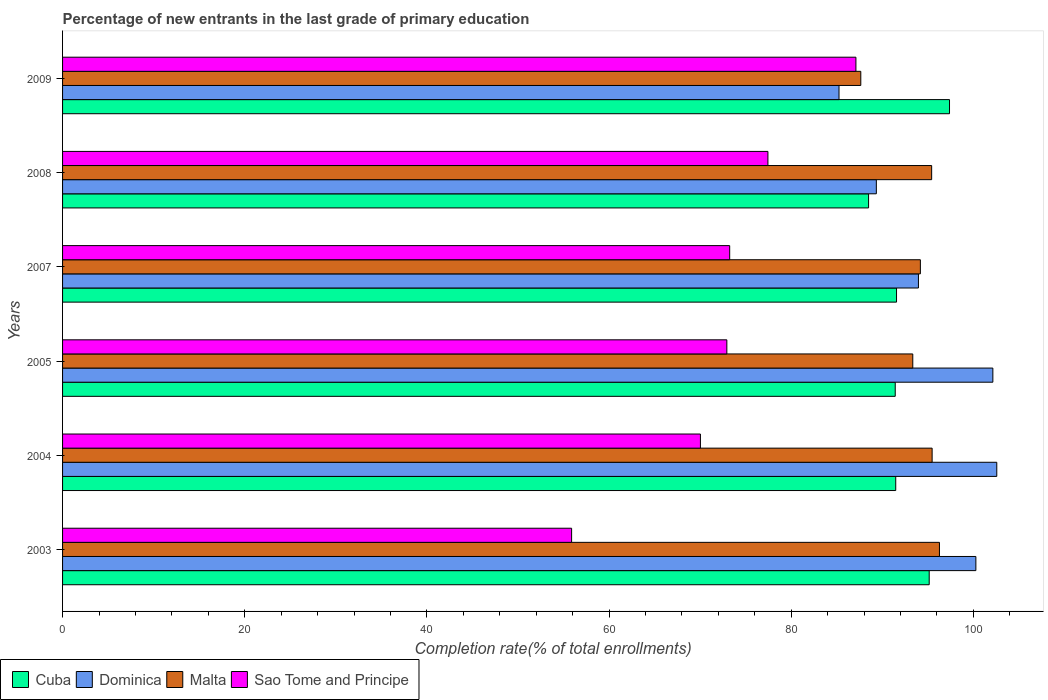How many different coloured bars are there?
Offer a terse response. 4. How many groups of bars are there?
Keep it short and to the point. 6. Are the number of bars per tick equal to the number of legend labels?
Give a very brief answer. Yes. How many bars are there on the 1st tick from the top?
Offer a terse response. 4. How many bars are there on the 3rd tick from the bottom?
Make the answer very short. 4. What is the label of the 4th group of bars from the top?
Provide a short and direct response. 2005. What is the percentage of new entrants in Sao Tome and Principe in 2003?
Ensure brevity in your answer.  55.89. Across all years, what is the maximum percentage of new entrants in Dominica?
Your response must be concise. 102.57. Across all years, what is the minimum percentage of new entrants in Cuba?
Provide a succinct answer. 88.5. What is the total percentage of new entrants in Cuba in the graph?
Give a very brief answer. 555.5. What is the difference between the percentage of new entrants in Dominica in 2003 and that in 2008?
Offer a very short reply. 10.93. What is the difference between the percentage of new entrants in Dominica in 2008 and the percentage of new entrants in Malta in 2007?
Provide a succinct answer. -4.83. What is the average percentage of new entrants in Malta per year?
Give a very brief answer. 93.72. In the year 2005, what is the difference between the percentage of new entrants in Dominica and percentage of new entrants in Sao Tome and Principe?
Keep it short and to the point. 29.21. What is the ratio of the percentage of new entrants in Sao Tome and Principe in 2005 to that in 2008?
Provide a succinct answer. 0.94. Is the difference between the percentage of new entrants in Dominica in 2007 and 2009 greater than the difference between the percentage of new entrants in Sao Tome and Principe in 2007 and 2009?
Make the answer very short. Yes. What is the difference between the highest and the second highest percentage of new entrants in Dominica?
Your answer should be compact. 0.43. What is the difference between the highest and the lowest percentage of new entrants in Sao Tome and Principe?
Your answer should be very brief. 31.22. In how many years, is the percentage of new entrants in Cuba greater than the average percentage of new entrants in Cuba taken over all years?
Provide a succinct answer. 2. Is the sum of the percentage of new entrants in Sao Tome and Principe in 2004 and 2005 greater than the maximum percentage of new entrants in Malta across all years?
Offer a very short reply. Yes. Is it the case that in every year, the sum of the percentage of new entrants in Malta and percentage of new entrants in Cuba is greater than the sum of percentage of new entrants in Sao Tome and Principe and percentage of new entrants in Dominica?
Ensure brevity in your answer.  Yes. What does the 2nd bar from the top in 2003 represents?
Give a very brief answer. Malta. What does the 3rd bar from the bottom in 2007 represents?
Provide a succinct answer. Malta. Is it the case that in every year, the sum of the percentage of new entrants in Dominica and percentage of new entrants in Sao Tome and Principe is greater than the percentage of new entrants in Cuba?
Offer a terse response. Yes. How many bars are there?
Offer a very short reply. 24. Are all the bars in the graph horizontal?
Give a very brief answer. Yes. What is the difference between two consecutive major ticks on the X-axis?
Your answer should be very brief. 20. Are the values on the major ticks of X-axis written in scientific E-notation?
Give a very brief answer. No. Does the graph contain grids?
Offer a terse response. No. Where does the legend appear in the graph?
Provide a short and direct response. Bottom left. How are the legend labels stacked?
Your response must be concise. Horizontal. What is the title of the graph?
Your answer should be compact. Percentage of new entrants in the last grade of primary education. Does "Iran" appear as one of the legend labels in the graph?
Keep it short and to the point. No. What is the label or title of the X-axis?
Provide a short and direct response. Completion rate(% of total enrollments). What is the Completion rate(% of total enrollments) of Cuba in 2003?
Give a very brief answer. 95.15. What is the Completion rate(% of total enrollments) of Dominica in 2003?
Keep it short and to the point. 100.28. What is the Completion rate(% of total enrollments) of Malta in 2003?
Give a very brief answer. 96.28. What is the Completion rate(% of total enrollments) in Sao Tome and Principe in 2003?
Ensure brevity in your answer.  55.89. What is the Completion rate(% of total enrollments) of Cuba in 2004?
Give a very brief answer. 91.48. What is the Completion rate(% of total enrollments) of Dominica in 2004?
Offer a very short reply. 102.57. What is the Completion rate(% of total enrollments) in Malta in 2004?
Your response must be concise. 95.47. What is the Completion rate(% of total enrollments) of Sao Tome and Principe in 2004?
Make the answer very short. 70.03. What is the Completion rate(% of total enrollments) in Cuba in 2005?
Keep it short and to the point. 91.42. What is the Completion rate(% of total enrollments) in Dominica in 2005?
Offer a terse response. 102.14. What is the Completion rate(% of total enrollments) of Malta in 2005?
Keep it short and to the point. 93.35. What is the Completion rate(% of total enrollments) in Sao Tome and Principe in 2005?
Offer a terse response. 72.93. What is the Completion rate(% of total enrollments) in Cuba in 2007?
Ensure brevity in your answer.  91.57. What is the Completion rate(% of total enrollments) of Dominica in 2007?
Your answer should be very brief. 93.97. What is the Completion rate(% of total enrollments) in Malta in 2007?
Provide a succinct answer. 94.18. What is the Completion rate(% of total enrollments) of Sao Tome and Principe in 2007?
Offer a terse response. 73.25. What is the Completion rate(% of total enrollments) in Cuba in 2008?
Offer a very short reply. 88.5. What is the Completion rate(% of total enrollments) of Dominica in 2008?
Your response must be concise. 89.35. What is the Completion rate(% of total enrollments) of Malta in 2008?
Your answer should be very brief. 95.42. What is the Completion rate(% of total enrollments) of Sao Tome and Principe in 2008?
Offer a terse response. 77.45. What is the Completion rate(% of total enrollments) in Cuba in 2009?
Keep it short and to the point. 97.38. What is the Completion rate(% of total enrollments) in Dominica in 2009?
Your answer should be compact. 85.25. What is the Completion rate(% of total enrollments) of Malta in 2009?
Make the answer very short. 87.64. What is the Completion rate(% of total enrollments) of Sao Tome and Principe in 2009?
Provide a short and direct response. 87.11. Across all years, what is the maximum Completion rate(% of total enrollments) of Cuba?
Give a very brief answer. 97.38. Across all years, what is the maximum Completion rate(% of total enrollments) in Dominica?
Provide a succinct answer. 102.57. Across all years, what is the maximum Completion rate(% of total enrollments) of Malta?
Make the answer very short. 96.28. Across all years, what is the maximum Completion rate(% of total enrollments) of Sao Tome and Principe?
Provide a succinct answer. 87.11. Across all years, what is the minimum Completion rate(% of total enrollments) of Cuba?
Your answer should be very brief. 88.5. Across all years, what is the minimum Completion rate(% of total enrollments) in Dominica?
Make the answer very short. 85.25. Across all years, what is the minimum Completion rate(% of total enrollments) of Malta?
Offer a terse response. 87.64. Across all years, what is the minimum Completion rate(% of total enrollments) of Sao Tome and Principe?
Offer a very short reply. 55.89. What is the total Completion rate(% of total enrollments) in Cuba in the graph?
Give a very brief answer. 555.5. What is the total Completion rate(% of total enrollments) of Dominica in the graph?
Offer a very short reply. 573.56. What is the total Completion rate(% of total enrollments) in Malta in the graph?
Offer a very short reply. 562.35. What is the total Completion rate(% of total enrollments) of Sao Tome and Principe in the graph?
Offer a terse response. 436.66. What is the difference between the Completion rate(% of total enrollments) in Cuba in 2003 and that in 2004?
Provide a succinct answer. 3.68. What is the difference between the Completion rate(% of total enrollments) in Dominica in 2003 and that in 2004?
Offer a very short reply. -2.3. What is the difference between the Completion rate(% of total enrollments) in Malta in 2003 and that in 2004?
Provide a short and direct response. 0.81. What is the difference between the Completion rate(% of total enrollments) in Sao Tome and Principe in 2003 and that in 2004?
Offer a very short reply. -14.14. What is the difference between the Completion rate(% of total enrollments) in Cuba in 2003 and that in 2005?
Provide a succinct answer. 3.73. What is the difference between the Completion rate(% of total enrollments) of Dominica in 2003 and that in 2005?
Your answer should be very brief. -1.86. What is the difference between the Completion rate(% of total enrollments) of Malta in 2003 and that in 2005?
Make the answer very short. 2.93. What is the difference between the Completion rate(% of total enrollments) of Sao Tome and Principe in 2003 and that in 2005?
Ensure brevity in your answer.  -17.04. What is the difference between the Completion rate(% of total enrollments) in Cuba in 2003 and that in 2007?
Offer a very short reply. 3.59. What is the difference between the Completion rate(% of total enrollments) of Dominica in 2003 and that in 2007?
Offer a terse response. 6.31. What is the difference between the Completion rate(% of total enrollments) in Malta in 2003 and that in 2007?
Keep it short and to the point. 2.1. What is the difference between the Completion rate(% of total enrollments) in Sao Tome and Principe in 2003 and that in 2007?
Your response must be concise. -17.36. What is the difference between the Completion rate(% of total enrollments) of Cuba in 2003 and that in 2008?
Keep it short and to the point. 6.66. What is the difference between the Completion rate(% of total enrollments) of Dominica in 2003 and that in 2008?
Your response must be concise. 10.93. What is the difference between the Completion rate(% of total enrollments) of Malta in 2003 and that in 2008?
Ensure brevity in your answer.  0.86. What is the difference between the Completion rate(% of total enrollments) in Sao Tome and Principe in 2003 and that in 2008?
Provide a succinct answer. -21.56. What is the difference between the Completion rate(% of total enrollments) in Cuba in 2003 and that in 2009?
Offer a very short reply. -2.23. What is the difference between the Completion rate(% of total enrollments) in Dominica in 2003 and that in 2009?
Give a very brief answer. 15.03. What is the difference between the Completion rate(% of total enrollments) in Malta in 2003 and that in 2009?
Offer a very short reply. 8.64. What is the difference between the Completion rate(% of total enrollments) in Sao Tome and Principe in 2003 and that in 2009?
Ensure brevity in your answer.  -31.22. What is the difference between the Completion rate(% of total enrollments) of Cuba in 2004 and that in 2005?
Offer a very short reply. 0.06. What is the difference between the Completion rate(% of total enrollments) of Dominica in 2004 and that in 2005?
Your response must be concise. 0.43. What is the difference between the Completion rate(% of total enrollments) of Malta in 2004 and that in 2005?
Your answer should be very brief. 2.12. What is the difference between the Completion rate(% of total enrollments) in Sao Tome and Principe in 2004 and that in 2005?
Your answer should be compact. -2.9. What is the difference between the Completion rate(% of total enrollments) in Cuba in 2004 and that in 2007?
Offer a very short reply. -0.09. What is the difference between the Completion rate(% of total enrollments) of Dominica in 2004 and that in 2007?
Your answer should be compact. 8.6. What is the difference between the Completion rate(% of total enrollments) of Malta in 2004 and that in 2007?
Your answer should be very brief. 1.29. What is the difference between the Completion rate(% of total enrollments) in Sao Tome and Principe in 2004 and that in 2007?
Provide a short and direct response. -3.21. What is the difference between the Completion rate(% of total enrollments) in Cuba in 2004 and that in 2008?
Offer a very short reply. 2.98. What is the difference between the Completion rate(% of total enrollments) of Dominica in 2004 and that in 2008?
Provide a succinct answer. 13.22. What is the difference between the Completion rate(% of total enrollments) of Malta in 2004 and that in 2008?
Ensure brevity in your answer.  0.05. What is the difference between the Completion rate(% of total enrollments) in Sao Tome and Principe in 2004 and that in 2008?
Provide a succinct answer. -7.41. What is the difference between the Completion rate(% of total enrollments) in Cuba in 2004 and that in 2009?
Your response must be concise. -5.91. What is the difference between the Completion rate(% of total enrollments) of Dominica in 2004 and that in 2009?
Offer a terse response. 17.32. What is the difference between the Completion rate(% of total enrollments) in Malta in 2004 and that in 2009?
Offer a very short reply. 7.83. What is the difference between the Completion rate(% of total enrollments) of Sao Tome and Principe in 2004 and that in 2009?
Offer a terse response. -17.07. What is the difference between the Completion rate(% of total enrollments) in Cuba in 2005 and that in 2007?
Make the answer very short. -0.14. What is the difference between the Completion rate(% of total enrollments) in Dominica in 2005 and that in 2007?
Make the answer very short. 8.17. What is the difference between the Completion rate(% of total enrollments) of Malta in 2005 and that in 2007?
Provide a succinct answer. -0.83. What is the difference between the Completion rate(% of total enrollments) in Sao Tome and Principe in 2005 and that in 2007?
Your response must be concise. -0.31. What is the difference between the Completion rate(% of total enrollments) of Cuba in 2005 and that in 2008?
Provide a succinct answer. 2.93. What is the difference between the Completion rate(% of total enrollments) of Dominica in 2005 and that in 2008?
Ensure brevity in your answer.  12.79. What is the difference between the Completion rate(% of total enrollments) of Malta in 2005 and that in 2008?
Provide a short and direct response. -2.07. What is the difference between the Completion rate(% of total enrollments) of Sao Tome and Principe in 2005 and that in 2008?
Provide a succinct answer. -4.51. What is the difference between the Completion rate(% of total enrollments) in Cuba in 2005 and that in 2009?
Ensure brevity in your answer.  -5.96. What is the difference between the Completion rate(% of total enrollments) in Dominica in 2005 and that in 2009?
Offer a very short reply. 16.89. What is the difference between the Completion rate(% of total enrollments) in Malta in 2005 and that in 2009?
Give a very brief answer. 5.71. What is the difference between the Completion rate(% of total enrollments) of Sao Tome and Principe in 2005 and that in 2009?
Keep it short and to the point. -14.17. What is the difference between the Completion rate(% of total enrollments) in Cuba in 2007 and that in 2008?
Keep it short and to the point. 3.07. What is the difference between the Completion rate(% of total enrollments) of Dominica in 2007 and that in 2008?
Ensure brevity in your answer.  4.62. What is the difference between the Completion rate(% of total enrollments) in Malta in 2007 and that in 2008?
Offer a terse response. -1.24. What is the difference between the Completion rate(% of total enrollments) in Sao Tome and Principe in 2007 and that in 2008?
Offer a very short reply. -4.2. What is the difference between the Completion rate(% of total enrollments) in Cuba in 2007 and that in 2009?
Your answer should be very brief. -5.82. What is the difference between the Completion rate(% of total enrollments) in Dominica in 2007 and that in 2009?
Your answer should be very brief. 8.72. What is the difference between the Completion rate(% of total enrollments) of Malta in 2007 and that in 2009?
Your answer should be very brief. 6.54. What is the difference between the Completion rate(% of total enrollments) in Sao Tome and Principe in 2007 and that in 2009?
Offer a terse response. -13.86. What is the difference between the Completion rate(% of total enrollments) in Cuba in 2008 and that in 2009?
Make the answer very short. -8.89. What is the difference between the Completion rate(% of total enrollments) of Dominica in 2008 and that in 2009?
Provide a short and direct response. 4.1. What is the difference between the Completion rate(% of total enrollments) of Malta in 2008 and that in 2009?
Your answer should be compact. 7.78. What is the difference between the Completion rate(% of total enrollments) of Sao Tome and Principe in 2008 and that in 2009?
Make the answer very short. -9.66. What is the difference between the Completion rate(% of total enrollments) in Cuba in 2003 and the Completion rate(% of total enrollments) in Dominica in 2004?
Your response must be concise. -7.42. What is the difference between the Completion rate(% of total enrollments) in Cuba in 2003 and the Completion rate(% of total enrollments) in Malta in 2004?
Make the answer very short. -0.32. What is the difference between the Completion rate(% of total enrollments) in Cuba in 2003 and the Completion rate(% of total enrollments) in Sao Tome and Principe in 2004?
Your answer should be compact. 25.12. What is the difference between the Completion rate(% of total enrollments) in Dominica in 2003 and the Completion rate(% of total enrollments) in Malta in 2004?
Provide a short and direct response. 4.8. What is the difference between the Completion rate(% of total enrollments) in Dominica in 2003 and the Completion rate(% of total enrollments) in Sao Tome and Principe in 2004?
Make the answer very short. 30.24. What is the difference between the Completion rate(% of total enrollments) of Malta in 2003 and the Completion rate(% of total enrollments) of Sao Tome and Principe in 2004?
Provide a short and direct response. 26.25. What is the difference between the Completion rate(% of total enrollments) of Cuba in 2003 and the Completion rate(% of total enrollments) of Dominica in 2005?
Offer a very short reply. -6.99. What is the difference between the Completion rate(% of total enrollments) of Cuba in 2003 and the Completion rate(% of total enrollments) of Malta in 2005?
Your answer should be very brief. 1.8. What is the difference between the Completion rate(% of total enrollments) in Cuba in 2003 and the Completion rate(% of total enrollments) in Sao Tome and Principe in 2005?
Your answer should be compact. 22.22. What is the difference between the Completion rate(% of total enrollments) in Dominica in 2003 and the Completion rate(% of total enrollments) in Malta in 2005?
Provide a short and direct response. 6.93. What is the difference between the Completion rate(% of total enrollments) of Dominica in 2003 and the Completion rate(% of total enrollments) of Sao Tome and Principe in 2005?
Provide a short and direct response. 27.34. What is the difference between the Completion rate(% of total enrollments) in Malta in 2003 and the Completion rate(% of total enrollments) in Sao Tome and Principe in 2005?
Offer a very short reply. 23.34. What is the difference between the Completion rate(% of total enrollments) in Cuba in 2003 and the Completion rate(% of total enrollments) in Dominica in 2007?
Ensure brevity in your answer.  1.18. What is the difference between the Completion rate(% of total enrollments) in Cuba in 2003 and the Completion rate(% of total enrollments) in Malta in 2007?
Give a very brief answer. 0.97. What is the difference between the Completion rate(% of total enrollments) in Cuba in 2003 and the Completion rate(% of total enrollments) in Sao Tome and Principe in 2007?
Offer a very short reply. 21.91. What is the difference between the Completion rate(% of total enrollments) of Dominica in 2003 and the Completion rate(% of total enrollments) of Malta in 2007?
Make the answer very short. 6.09. What is the difference between the Completion rate(% of total enrollments) of Dominica in 2003 and the Completion rate(% of total enrollments) of Sao Tome and Principe in 2007?
Provide a short and direct response. 27.03. What is the difference between the Completion rate(% of total enrollments) of Malta in 2003 and the Completion rate(% of total enrollments) of Sao Tome and Principe in 2007?
Make the answer very short. 23.03. What is the difference between the Completion rate(% of total enrollments) of Cuba in 2003 and the Completion rate(% of total enrollments) of Dominica in 2008?
Give a very brief answer. 5.8. What is the difference between the Completion rate(% of total enrollments) in Cuba in 2003 and the Completion rate(% of total enrollments) in Malta in 2008?
Make the answer very short. -0.27. What is the difference between the Completion rate(% of total enrollments) of Cuba in 2003 and the Completion rate(% of total enrollments) of Sao Tome and Principe in 2008?
Your answer should be compact. 17.71. What is the difference between the Completion rate(% of total enrollments) in Dominica in 2003 and the Completion rate(% of total enrollments) in Malta in 2008?
Make the answer very short. 4.85. What is the difference between the Completion rate(% of total enrollments) of Dominica in 2003 and the Completion rate(% of total enrollments) of Sao Tome and Principe in 2008?
Provide a short and direct response. 22.83. What is the difference between the Completion rate(% of total enrollments) of Malta in 2003 and the Completion rate(% of total enrollments) of Sao Tome and Principe in 2008?
Provide a succinct answer. 18.83. What is the difference between the Completion rate(% of total enrollments) of Cuba in 2003 and the Completion rate(% of total enrollments) of Dominica in 2009?
Make the answer very short. 9.9. What is the difference between the Completion rate(% of total enrollments) of Cuba in 2003 and the Completion rate(% of total enrollments) of Malta in 2009?
Make the answer very short. 7.51. What is the difference between the Completion rate(% of total enrollments) in Cuba in 2003 and the Completion rate(% of total enrollments) in Sao Tome and Principe in 2009?
Ensure brevity in your answer.  8.05. What is the difference between the Completion rate(% of total enrollments) in Dominica in 2003 and the Completion rate(% of total enrollments) in Malta in 2009?
Provide a succinct answer. 12.64. What is the difference between the Completion rate(% of total enrollments) of Dominica in 2003 and the Completion rate(% of total enrollments) of Sao Tome and Principe in 2009?
Offer a very short reply. 13.17. What is the difference between the Completion rate(% of total enrollments) of Malta in 2003 and the Completion rate(% of total enrollments) of Sao Tome and Principe in 2009?
Your answer should be very brief. 9.17. What is the difference between the Completion rate(% of total enrollments) in Cuba in 2004 and the Completion rate(% of total enrollments) in Dominica in 2005?
Give a very brief answer. -10.66. What is the difference between the Completion rate(% of total enrollments) of Cuba in 2004 and the Completion rate(% of total enrollments) of Malta in 2005?
Keep it short and to the point. -1.87. What is the difference between the Completion rate(% of total enrollments) of Cuba in 2004 and the Completion rate(% of total enrollments) of Sao Tome and Principe in 2005?
Offer a very short reply. 18.54. What is the difference between the Completion rate(% of total enrollments) of Dominica in 2004 and the Completion rate(% of total enrollments) of Malta in 2005?
Provide a short and direct response. 9.22. What is the difference between the Completion rate(% of total enrollments) in Dominica in 2004 and the Completion rate(% of total enrollments) in Sao Tome and Principe in 2005?
Keep it short and to the point. 29.64. What is the difference between the Completion rate(% of total enrollments) in Malta in 2004 and the Completion rate(% of total enrollments) in Sao Tome and Principe in 2005?
Offer a terse response. 22.54. What is the difference between the Completion rate(% of total enrollments) of Cuba in 2004 and the Completion rate(% of total enrollments) of Dominica in 2007?
Give a very brief answer. -2.49. What is the difference between the Completion rate(% of total enrollments) in Cuba in 2004 and the Completion rate(% of total enrollments) in Malta in 2007?
Provide a short and direct response. -2.71. What is the difference between the Completion rate(% of total enrollments) of Cuba in 2004 and the Completion rate(% of total enrollments) of Sao Tome and Principe in 2007?
Keep it short and to the point. 18.23. What is the difference between the Completion rate(% of total enrollments) in Dominica in 2004 and the Completion rate(% of total enrollments) in Malta in 2007?
Offer a terse response. 8.39. What is the difference between the Completion rate(% of total enrollments) in Dominica in 2004 and the Completion rate(% of total enrollments) in Sao Tome and Principe in 2007?
Offer a terse response. 29.32. What is the difference between the Completion rate(% of total enrollments) of Malta in 2004 and the Completion rate(% of total enrollments) of Sao Tome and Principe in 2007?
Your answer should be very brief. 22.23. What is the difference between the Completion rate(% of total enrollments) of Cuba in 2004 and the Completion rate(% of total enrollments) of Dominica in 2008?
Offer a terse response. 2.13. What is the difference between the Completion rate(% of total enrollments) of Cuba in 2004 and the Completion rate(% of total enrollments) of Malta in 2008?
Your answer should be compact. -3.94. What is the difference between the Completion rate(% of total enrollments) of Cuba in 2004 and the Completion rate(% of total enrollments) of Sao Tome and Principe in 2008?
Your response must be concise. 14.03. What is the difference between the Completion rate(% of total enrollments) of Dominica in 2004 and the Completion rate(% of total enrollments) of Malta in 2008?
Keep it short and to the point. 7.15. What is the difference between the Completion rate(% of total enrollments) in Dominica in 2004 and the Completion rate(% of total enrollments) in Sao Tome and Principe in 2008?
Keep it short and to the point. 25.13. What is the difference between the Completion rate(% of total enrollments) of Malta in 2004 and the Completion rate(% of total enrollments) of Sao Tome and Principe in 2008?
Your answer should be very brief. 18.03. What is the difference between the Completion rate(% of total enrollments) of Cuba in 2004 and the Completion rate(% of total enrollments) of Dominica in 2009?
Offer a terse response. 6.23. What is the difference between the Completion rate(% of total enrollments) of Cuba in 2004 and the Completion rate(% of total enrollments) of Malta in 2009?
Your answer should be very brief. 3.84. What is the difference between the Completion rate(% of total enrollments) of Cuba in 2004 and the Completion rate(% of total enrollments) of Sao Tome and Principe in 2009?
Keep it short and to the point. 4.37. What is the difference between the Completion rate(% of total enrollments) of Dominica in 2004 and the Completion rate(% of total enrollments) of Malta in 2009?
Keep it short and to the point. 14.93. What is the difference between the Completion rate(% of total enrollments) in Dominica in 2004 and the Completion rate(% of total enrollments) in Sao Tome and Principe in 2009?
Offer a very short reply. 15.47. What is the difference between the Completion rate(% of total enrollments) in Malta in 2004 and the Completion rate(% of total enrollments) in Sao Tome and Principe in 2009?
Offer a terse response. 8.37. What is the difference between the Completion rate(% of total enrollments) of Cuba in 2005 and the Completion rate(% of total enrollments) of Dominica in 2007?
Offer a very short reply. -2.55. What is the difference between the Completion rate(% of total enrollments) of Cuba in 2005 and the Completion rate(% of total enrollments) of Malta in 2007?
Your answer should be compact. -2.76. What is the difference between the Completion rate(% of total enrollments) of Cuba in 2005 and the Completion rate(% of total enrollments) of Sao Tome and Principe in 2007?
Offer a terse response. 18.18. What is the difference between the Completion rate(% of total enrollments) of Dominica in 2005 and the Completion rate(% of total enrollments) of Malta in 2007?
Keep it short and to the point. 7.96. What is the difference between the Completion rate(% of total enrollments) in Dominica in 2005 and the Completion rate(% of total enrollments) in Sao Tome and Principe in 2007?
Keep it short and to the point. 28.89. What is the difference between the Completion rate(% of total enrollments) of Malta in 2005 and the Completion rate(% of total enrollments) of Sao Tome and Principe in 2007?
Offer a very short reply. 20.1. What is the difference between the Completion rate(% of total enrollments) in Cuba in 2005 and the Completion rate(% of total enrollments) in Dominica in 2008?
Your answer should be compact. 2.07. What is the difference between the Completion rate(% of total enrollments) in Cuba in 2005 and the Completion rate(% of total enrollments) in Malta in 2008?
Offer a very short reply. -4. What is the difference between the Completion rate(% of total enrollments) of Cuba in 2005 and the Completion rate(% of total enrollments) of Sao Tome and Principe in 2008?
Your answer should be compact. 13.98. What is the difference between the Completion rate(% of total enrollments) in Dominica in 2005 and the Completion rate(% of total enrollments) in Malta in 2008?
Provide a short and direct response. 6.72. What is the difference between the Completion rate(% of total enrollments) of Dominica in 2005 and the Completion rate(% of total enrollments) of Sao Tome and Principe in 2008?
Keep it short and to the point. 24.7. What is the difference between the Completion rate(% of total enrollments) in Malta in 2005 and the Completion rate(% of total enrollments) in Sao Tome and Principe in 2008?
Keep it short and to the point. 15.9. What is the difference between the Completion rate(% of total enrollments) of Cuba in 2005 and the Completion rate(% of total enrollments) of Dominica in 2009?
Your response must be concise. 6.17. What is the difference between the Completion rate(% of total enrollments) of Cuba in 2005 and the Completion rate(% of total enrollments) of Malta in 2009?
Provide a short and direct response. 3.78. What is the difference between the Completion rate(% of total enrollments) in Cuba in 2005 and the Completion rate(% of total enrollments) in Sao Tome and Principe in 2009?
Your answer should be compact. 4.32. What is the difference between the Completion rate(% of total enrollments) in Dominica in 2005 and the Completion rate(% of total enrollments) in Malta in 2009?
Provide a succinct answer. 14.5. What is the difference between the Completion rate(% of total enrollments) of Dominica in 2005 and the Completion rate(% of total enrollments) of Sao Tome and Principe in 2009?
Keep it short and to the point. 15.03. What is the difference between the Completion rate(% of total enrollments) in Malta in 2005 and the Completion rate(% of total enrollments) in Sao Tome and Principe in 2009?
Give a very brief answer. 6.24. What is the difference between the Completion rate(% of total enrollments) in Cuba in 2007 and the Completion rate(% of total enrollments) in Dominica in 2008?
Give a very brief answer. 2.22. What is the difference between the Completion rate(% of total enrollments) of Cuba in 2007 and the Completion rate(% of total enrollments) of Malta in 2008?
Your answer should be compact. -3.86. What is the difference between the Completion rate(% of total enrollments) in Cuba in 2007 and the Completion rate(% of total enrollments) in Sao Tome and Principe in 2008?
Ensure brevity in your answer.  14.12. What is the difference between the Completion rate(% of total enrollments) in Dominica in 2007 and the Completion rate(% of total enrollments) in Malta in 2008?
Provide a short and direct response. -1.45. What is the difference between the Completion rate(% of total enrollments) of Dominica in 2007 and the Completion rate(% of total enrollments) of Sao Tome and Principe in 2008?
Provide a short and direct response. 16.53. What is the difference between the Completion rate(% of total enrollments) of Malta in 2007 and the Completion rate(% of total enrollments) of Sao Tome and Principe in 2008?
Ensure brevity in your answer.  16.74. What is the difference between the Completion rate(% of total enrollments) of Cuba in 2007 and the Completion rate(% of total enrollments) of Dominica in 2009?
Your answer should be compact. 6.32. What is the difference between the Completion rate(% of total enrollments) in Cuba in 2007 and the Completion rate(% of total enrollments) in Malta in 2009?
Your answer should be very brief. 3.92. What is the difference between the Completion rate(% of total enrollments) of Cuba in 2007 and the Completion rate(% of total enrollments) of Sao Tome and Principe in 2009?
Ensure brevity in your answer.  4.46. What is the difference between the Completion rate(% of total enrollments) in Dominica in 2007 and the Completion rate(% of total enrollments) in Malta in 2009?
Your response must be concise. 6.33. What is the difference between the Completion rate(% of total enrollments) of Dominica in 2007 and the Completion rate(% of total enrollments) of Sao Tome and Principe in 2009?
Offer a very short reply. 6.86. What is the difference between the Completion rate(% of total enrollments) of Malta in 2007 and the Completion rate(% of total enrollments) of Sao Tome and Principe in 2009?
Offer a terse response. 7.08. What is the difference between the Completion rate(% of total enrollments) of Cuba in 2008 and the Completion rate(% of total enrollments) of Dominica in 2009?
Make the answer very short. 3.25. What is the difference between the Completion rate(% of total enrollments) of Cuba in 2008 and the Completion rate(% of total enrollments) of Malta in 2009?
Make the answer very short. 0.86. What is the difference between the Completion rate(% of total enrollments) of Cuba in 2008 and the Completion rate(% of total enrollments) of Sao Tome and Principe in 2009?
Your answer should be very brief. 1.39. What is the difference between the Completion rate(% of total enrollments) of Dominica in 2008 and the Completion rate(% of total enrollments) of Malta in 2009?
Keep it short and to the point. 1.71. What is the difference between the Completion rate(% of total enrollments) in Dominica in 2008 and the Completion rate(% of total enrollments) in Sao Tome and Principe in 2009?
Your answer should be compact. 2.24. What is the difference between the Completion rate(% of total enrollments) in Malta in 2008 and the Completion rate(% of total enrollments) in Sao Tome and Principe in 2009?
Your answer should be very brief. 8.32. What is the average Completion rate(% of total enrollments) of Cuba per year?
Give a very brief answer. 92.58. What is the average Completion rate(% of total enrollments) of Dominica per year?
Provide a short and direct response. 95.59. What is the average Completion rate(% of total enrollments) in Malta per year?
Your response must be concise. 93.72. What is the average Completion rate(% of total enrollments) in Sao Tome and Principe per year?
Your answer should be compact. 72.78. In the year 2003, what is the difference between the Completion rate(% of total enrollments) of Cuba and Completion rate(% of total enrollments) of Dominica?
Your answer should be compact. -5.12. In the year 2003, what is the difference between the Completion rate(% of total enrollments) in Cuba and Completion rate(% of total enrollments) in Malta?
Offer a very short reply. -1.13. In the year 2003, what is the difference between the Completion rate(% of total enrollments) in Cuba and Completion rate(% of total enrollments) in Sao Tome and Principe?
Ensure brevity in your answer.  39.26. In the year 2003, what is the difference between the Completion rate(% of total enrollments) of Dominica and Completion rate(% of total enrollments) of Malta?
Your answer should be compact. 4. In the year 2003, what is the difference between the Completion rate(% of total enrollments) in Dominica and Completion rate(% of total enrollments) in Sao Tome and Principe?
Your answer should be compact. 44.39. In the year 2003, what is the difference between the Completion rate(% of total enrollments) in Malta and Completion rate(% of total enrollments) in Sao Tome and Principe?
Provide a short and direct response. 40.39. In the year 2004, what is the difference between the Completion rate(% of total enrollments) in Cuba and Completion rate(% of total enrollments) in Dominica?
Provide a short and direct response. -11.09. In the year 2004, what is the difference between the Completion rate(% of total enrollments) of Cuba and Completion rate(% of total enrollments) of Malta?
Offer a terse response. -4. In the year 2004, what is the difference between the Completion rate(% of total enrollments) in Cuba and Completion rate(% of total enrollments) in Sao Tome and Principe?
Offer a terse response. 21.44. In the year 2004, what is the difference between the Completion rate(% of total enrollments) in Dominica and Completion rate(% of total enrollments) in Malta?
Make the answer very short. 7.1. In the year 2004, what is the difference between the Completion rate(% of total enrollments) in Dominica and Completion rate(% of total enrollments) in Sao Tome and Principe?
Give a very brief answer. 32.54. In the year 2004, what is the difference between the Completion rate(% of total enrollments) of Malta and Completion rate(% of total enrollments) of Sao Tome and Principe?
Ensure brevity in your answer.  25.44. In the year 2005, what is the difference between the Completion rate(% of total enrollments) of Cuba and Completion rate(% of total enrollments) of Dominica?
Keep it short and to the point. -10.72. In the year 2005, what is the difference between the Completion rate(% of total enrollments) in Cuba and Completion rate(% of total enrollments) in Malta?
Offer a very short reply. -1.93. In the year 2005, what is the difference between the Completion rate(% of total enrollments) of Cuba and Completion rate(% of total enrollments) of Sao Tome and Principe?
Your response must be concise. 18.49. In the year 2005, what is the difference between the Completion rate(% of total enrollments) of Dominica and Completion rate(% of total enrollments) of Malta?
Keep it short and to the point. 8.79. In the year 2005, what is the difference between the Completion rate(% of total enrollments) of Dominica and Completion rate(% of total enrollments) of Sao Tome and Principe?
Keep it short and to the point. 29.21. In the year 2005, what is the difference between the Completion rate(% of total enrollments) in Malta and Completion rate(% of total enrollments) in Sao Tome and Principe?
Provide a short and direct response. 20.41. In the year 2007, what is the difference between the Completion rate(% of total enrollments) of Cuba and Completion rate(% of total enrollments) of Dominica?
Make the answer very short. -2.41. In the year 2007, what is the difference between the Completion rate(% of total enrollments) of Cuba and Completion rate(% of total enrollments) of Malta?
Make the answer very short. -2.62. In the year 2007, what is the difference between the Completion rate(% of total enrollments) of Cuba and Completion rate(% of total enrollments) of Sao Tome and Principe?
Offer a terse response. 18.32. In the year 2007, what is the difference between the Completion rate(% of total enrollments) of Dominica and Completion rate(% of total enrollments) of Malta?
Offer a terse response. -0.21. In the year 2007, what is the difference between the Completion rate(% of total enrollments) of Dominica and Completion rate(% of total enrollments) of Sao Tome and Principe?
Offer a terse response. 20.72. In the year 2007, what is the difference between the Completion rate(% of total enrollments) in Malta and Completion rate(% of total enrollments) in Sao Tome and Principe?
Your response must be concise. 20.94. In the year 2008, what is the difference between the Completion rate(% of total enrollments) in Cuba and Completion rate(% of total enrollments) in Dominica?
Ensure brevity in your answer.  -0.85. In the year 2008, what is the difference between the Completion rate(% of total enrollments) of Cuba and Completion rate(% of total enrollments) of Malta?
Provide a succinct answer. -6.93. In the year 2008, what is the difference between the Completion rate(% of total enrollments) in Cuba and Completion rate(% of total enrollments) in Sao Tome and Principe?
Your response must be concise. 11.05. In the year 2008, what is the difference between the Completion rate(% of total enrollments) in Dominica and Completion rate(% of total enrollments) in Malta?
Offer a very short reply. -6.07. In the year 2008, what is the difference between the Completion rate(% of total enrollments) of Dominica and Completion rate(% of total enrollments) of Sao Tome and Principe?
Ensure brevity in your answer.  11.9. In the year 2008, what is the difference between the Completion rate(% of total enrollments) of Malta and Completion rate(% of total enrollments) of Sao Tome and Principe?
Provide a short and direct response. 17.98. In the year 2009, what is the difference between the Completion rate(% of total enrollments) of Cuba and Completion rate(% of total enrollments) of Dominica?
Provide a succinct answer. 12.13. In the year 2009, what is the difference between the Completion rate(% of total enrollments) of Cuba and Completion rate(% of total enrollments) of Malta?
Your answer should be very brief. 9.74. In the year 2009, what is the difference between the Completion rate(% of total enrollments) of Cuba and Completion rate(% of total enrollments) of Sao Tome and Principe?
Give a very brief answer. 10.28. In the year 2009, what is the difference between the Completion rate(% of total enrollments) in Dominica and Completion rate(% of total enrollments) in Malta?
Offer a terse response. -2.39. In the year 2009, what is the difference between the Completion rate(% of total enrollments) in Dominica and Completion rate(% of total enrollments) in Sao Tome and Principe?
Offer a very short reply. -1.86. In the year 2009, what is the difference between the Completion rate(% of total enrollments) of Malta and Completion rate(% of total enrollments) of Sao Tome and Principe?
Your response must be concise. 0.53. What is the ratio of the Completion rate(% of total enrollments) in Cuba in 2003 to that in 2004?
Offer a very short reply. 1.04. What is the ratio of the Completion rate(% of total enrollments) in Dominica in 2003 to that in 2004?
Give a very brief answer. 0.98. What is the ratio of the Completion rate(% of total enrollments) of Malta in 2003 to that in 2004?
Provide a short and direct response. 1.01. What is the ratio of the Completion rate(% of total enrollments) of Sao Tome and Principe in 2003 to that in 2004?
Keep it short and to the point. 0.8. What is the ratio of the Completion rate(% of total enrollments) of Cuba in 2003 to that in 2005?
Give a very brief answer. 1.04. What is the ratio of the Completion rate(% of total enrollments) of Dominica in 2003 to that in 2005?
Give a very brief answer. 0.98. What is the ratio of the Completion rate(% of total enrollments) in Malta in 2003 to that in 2005?
Give a very brief answer. 1.03. What is the ratio of the Completion rate(% of total enrollments) of Sao Tome and Principe in 2003 to that in 2005?
Provide a succinct answer. 0.77. What is the ratio of the Completion rate(% of total enrollments) in Cuba in 2003 to that in 2007?
Provide a short and direct response. 1.04. What is the ratio of the Completion rate(% of total enrollments) in Dominica in 2003 to that in 2007?
Make the answer very short. 1.07. What is the ratio of the Completion rate(% of total enrollments) of Malta in 2003 to that in 2007?
Provide a short and direct response. 1.02. What is the ratio of the Completion rate(% of total enrollments) of Sao Tome and Principe in 2003 to that in 2007?
Make the answer very short. 0.76. What is the ratio of the Completion rate(% of total enrollments) in Cuba in 2003 to that in 2008?
Ensure brevity in your answer.  1.08. What is the ratio of the Completion rate(% of total enrollments) in Dominica in 2003 to that in 2008?
Your response must be concise. 1.12. What is the ratio of the Completion rate(% of total enrollments) in Sao Tome and Principe in 2003 to that in 2008?
Your answer should be very brief. 0.72. What is the ratio of the Completion rate(% of total enrollments) in Cuba in 2003 to that in 2009?
Give a very brief answer. 0.98. What is the ratio of the Completion rate(% of total enrollments) in Dominica in 2003 to that in 2009?
Keep it short and to the point. 1.18. What is the ratio of the Completion rate(% of total enrollments) of Malta in 2003 to that in 2009?
Give a very brief answer. 1.1. What is the ratio of the Completion rate(% of total enrollments) in Sao Tome and Principe in 2003 to that in 2009?
Your response must be concise. 0.64. What is the ratio of the Completion rate(% of total enrollments) in Dominica in 2004 to that in 2005?
Provide a short and direct response. 1. What is the ratio of the Completion rate(% of total enrollments) of Malta in 2004 to that in 2005?
Your response must be concise. 1.02. What is the ratio of the Completion rate(% of total enrollments) of Sao Tome and Principe in 2004 to that in 2005?
Give a very brief answer. 0.96. What is the ratio of the Completion rate(% of total enrollments) of Cuba in 2004 to that in 2007?
Your answer should be very brief. 1. What is the ratio of the Completion rate(% of total enrollments) in Dominica in 2004 to that in 2007?
Your response must be concise. 1.09. What is the ratio of the Completion rate(% of total enrollments) of Malta in 2004 to that in 2007?
Make the answer very short. 1.01. What is the ratio of the Completion rate(% of total enrollments) of Sao Tome and Principe in 2004 to that in 2007?
Your answer should be very brief. 0.96. What is the ratio of the Completion rate(% of total enrollments) in Cuba in 2004 to that in 2008?
Your answer should be very brief. 1.03. What is the ratio of the Completion rate(% of total enrollments) in Dominica in 2004 to that in 2008?
Your answer should be compact. 1.15. What is the ratio of the Completion rate(% of total enrollments) in Sao Tome and Principe in 2004 to that in 2008?
Ensure brevity in your answer.  0.9. What is the ratio of the Completion rate(% of total enrollments) in Cuba in 2004 to that in 2009?
Offer a very short reply. 0.94. What is the ratio of the Completion rate(% of total enrollments) in Dominica in 2004 to that in 2009?
Offer a terse response. 1.2. What is the ratio of the Completion rate(% of total enrollments) in Malta in 2004 to that in 2009?
Provide a short and direct response. 1.09. What is the ratio of the Completion rate(% of total enrollments) in Sao Tome and Principe in 2004 to that in 2009?
Give a very brief answer. 0.8. What is the ratio of the Completion rate(% of total enrollments) of Cuba in 2005 to that in 2007?
Provide a short and direct response. 1. What is the ratio of the Completion rate(% of total enrollments) of Dominica in 2005 to that in 2007?
Provide a succinct answer. 1.09. What is the ratio of the Completion rate(% of total enrollments) in Sao Tome and Principe in 2005 to that in 2007?
Provide a succinct answer. 1. What is the ratio of the Completion rate(% of total enrollments) of Cuba in 2005 to that in 2008?
Offer a terse response. 1.03. What is the ratio of the Completion rate(% of total enrollments) of Dominica in 2005 to that in 2008?
Your answer should be very brief. 1.14. What is the ratio of the Completion rate(% of total enrollments) in Malta in 2005 to that in 2008?
Provide a short and direct response. 0.98. What is the ratio of the Completion rate(% of total enrollments) in Sao Tome and Principe in 2005 to that in 2008?
Provide a succinct answer. 0.94. What is the ratio of the Completion rate(% of total enrollments) of Cuba in 2005 to that in 2009?
Offer a terse response. 0.94. What is the ratio of the Completion rate(% of total enrollments) of Dominica in 2005 to that in 2009?
Provide a succinct answer. 1.2. What is the ratio of the Completion rate(% of total enrollments) in Malta in 2005 to that in 2009?
Keep it short and to the point. 1.07. What is the ratio of the Completion rate(% of total enrollments) in Sao Tome and Principe in 2005 to that in 2009?
Give a very brief answer. 0.84. What is the ratio of the Completion rate(% of total enrollments) in Cuba in 2007 to that in 2008?
Ensure brevity in your answer.  1.03. What is the ratio of the Completion rate(% of total enrollments) in Dominica in 2007 to that in 2008?
Offer a terse response. 1.05. What is the ratio of the Completion rate(% of total enrollments) in Sao Tome and Principe in 2007 to that in 2008?
Provide a short and direct response. 0.95. What is the ratio of the Completion rate(% of total enrollments) of Cuba in 2007 to that in 2009?
Your response must be concise. 0.94. What is the ratio of the Completion rate(% of total enrollments) in Dominica in 2007 to that in 2009?
Your answer should be very brief. 1.1. What is the ratio of the Completion rate(% of total enrollments) of Malta in 2007 to that in 2009?
Keep it short and to the point. 1.07. What is the ratio of the Completion rate(% of total enrollments) in Sao Tome and Principe in 2007 to that in 2009?
Provide a succinct answer. 0.84. What is the ratio of the Completion rate(% of total enrollments) of Cuba in 2008 to that in 2009?
Provide a succinct answer. 0.91. What is the ratio of the Completion rate(% of total enrollments) in Dominica in 2008 to that in 2009?
Keep it short and to the point. 1.05. What is the ratio of the Completion rate(% of total enrollments) in Malta in 2008 to that in 2009?
Offer a terse response. 1.09. What is the ratio of the Completion rate(% of total enrollments) in Sao Tome and Principe in 2008 to that in 2009?
Your response must be concise. 0.89. What is the difference between the highest and the second highest Completion rate(% of total enrollments) in Cuba?
Your answer should be compact. 2.23. What is the difference between the highest and the second highest Completion rate(% of total enrollments) in Dominica?
Your response must be concise. 0.43. What is the difference between the highest and the second highest Completion rate(% of total enrollments) of Malta?
Give a very brief answer. 0.81. What is the difference between the highest and the second highest Completion rate(% of total enrollments) in Sao Tome and Principe?
Make the answer very short. 9.66. What is the difference between the highest and the lowest Completion rate(% of total enrollments) of Cuba?
Your response must be concise. 8.89. What is the difference between the highest and the lowest Completion rate(% of total enrollments) of Dominica?
Your answer should be very brief. 17.32. What is the difference between the highest and the lowest Completion rate(% of total enrollments) of Malta?
Offer a terse response. 8.64. What is the difference between the highest and the lowest Completion rate(% of total enrollments) of Sao Tome and Principe?
Your answer should be compact. 31.22. 